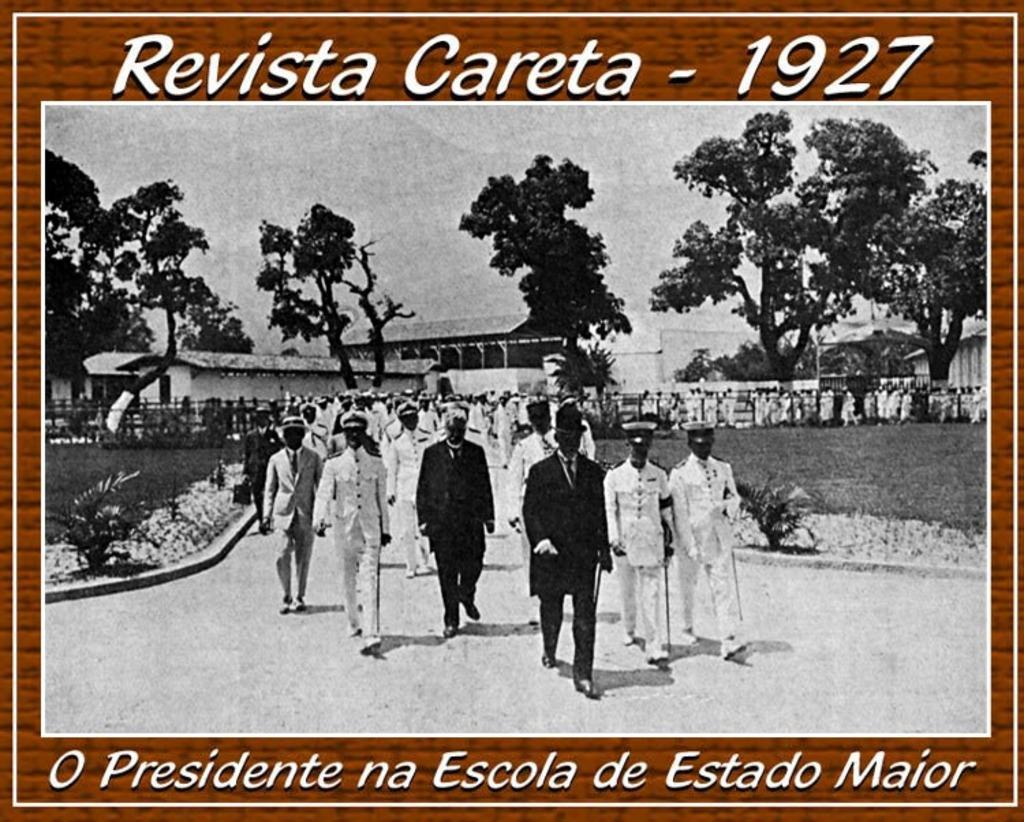<image>
Describe the image concisely. a black and white photo of people walking on a sidewalk in revista careta in 1927 